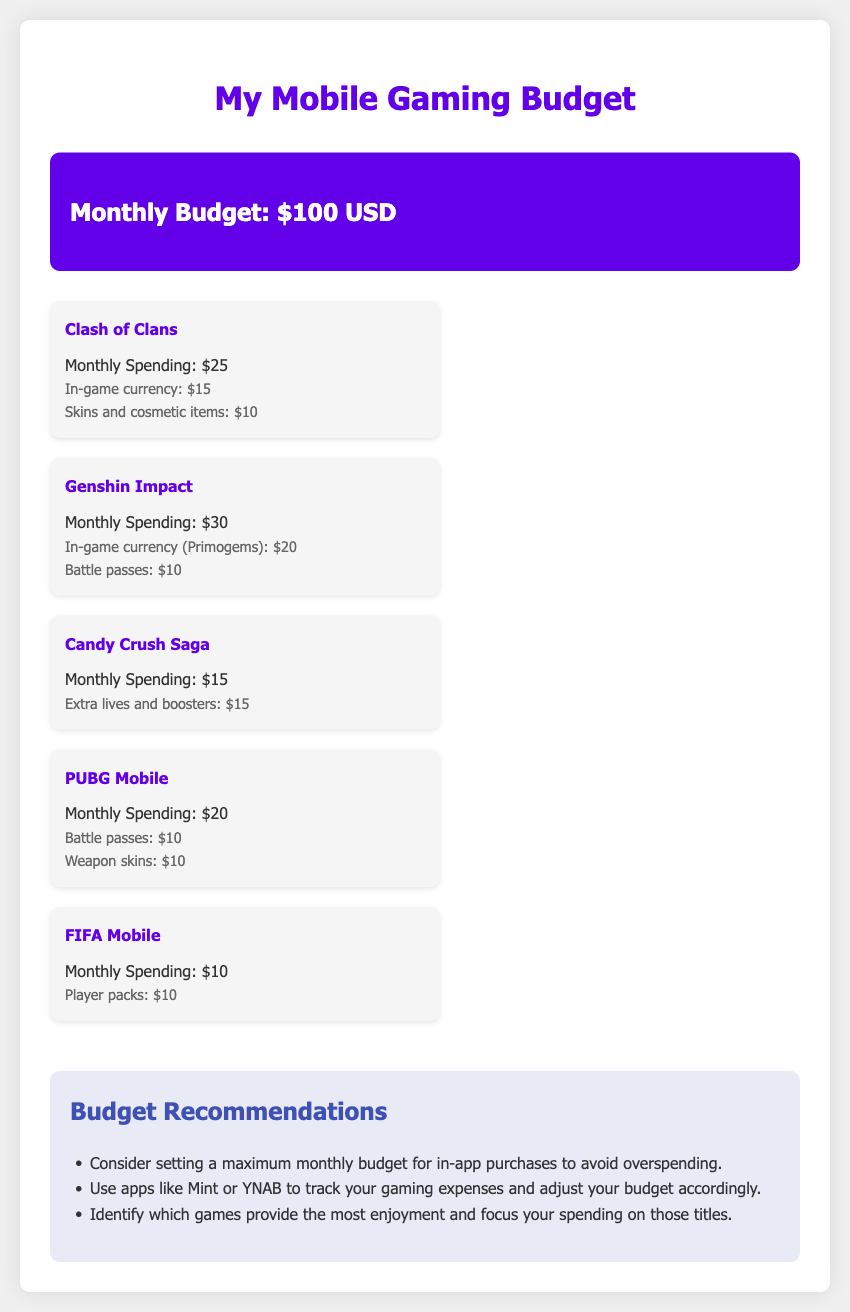What is the monthly budget? The document states the monthly budget at the top.
Answer: $100 USD How much is spent on Genshin Impact? The spending for Genshin Impact is mentioned in the game breakdown section.
Answer: $30 What are the in-game currency expenses for Clash of Clans? The specific types of spending for Clash of Clans are outlined.
Answer: $15 Which game has the lowest monthly spending? The document lists the monthly spending for each game, the lowest amount is considered.
Answer: FIFA Mobile How much is spent on extra lives and boosters in Candy Crush Saga? The document details the specific spending categories for Candy Crush Saga.
Answer: $15 What is the total spending on PUBG Mobile? The total monthly spending for PUBG Mobile is listed in the breakdown.
Answer: $20 How much of the overall budget is spent on in-game currency across all games? The in-game currency spending from each game can be totaled for this calculation.
Answer: $50 What is one budgeting recommendation provided in the document? The document includes specific recommendations for gaming budgeting.
Answer: Set a maximum monthly budget 